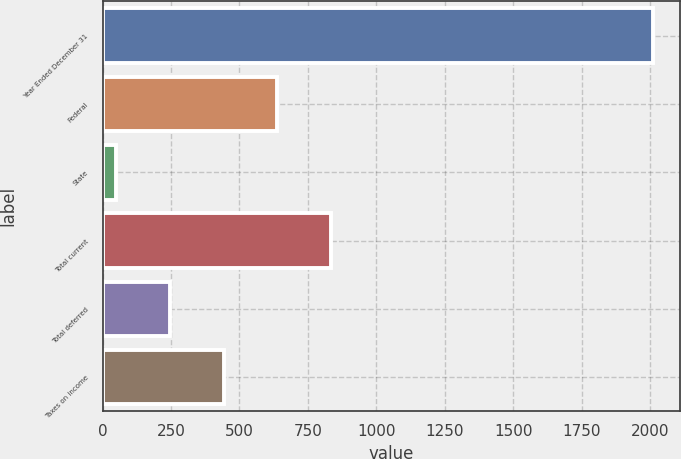<chart> <loc_0><loc_0><loc_500><loc_500><bar_chart><fcel>Year Ended December 31<fcel>Federal<fcel>State<fcel>Total current<fcel>Total deferred<fcel>Taxes on income<nl><fcel>2010<fcel>638<fcel>50<fcel>834<fcel>246<fcel>442<nl></chart> 